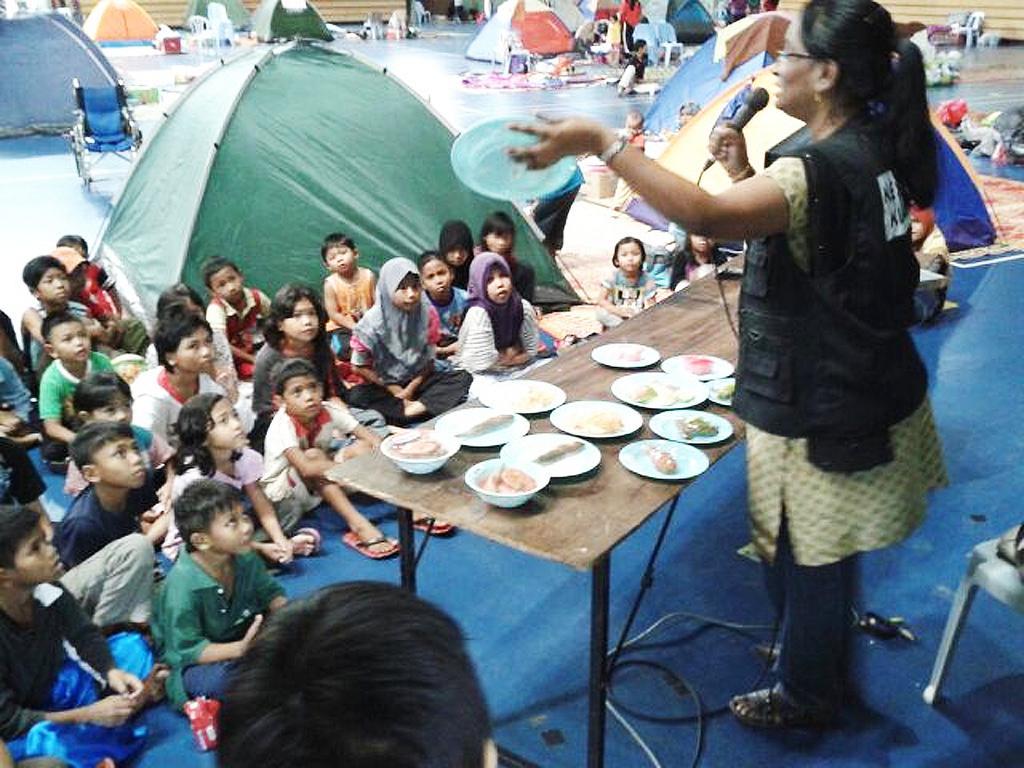How would you summarize this image in a sentence or two? In this image, we can see a woman holding microphone. She stand near table. On the top of the table,we can see some plates and a bowl. The woman is wearing same jacket and cream color dress. Here we can see some chair. And group of people are sat on the ground. Here we can see some tents. And the woman is holding plate on his left hand. 